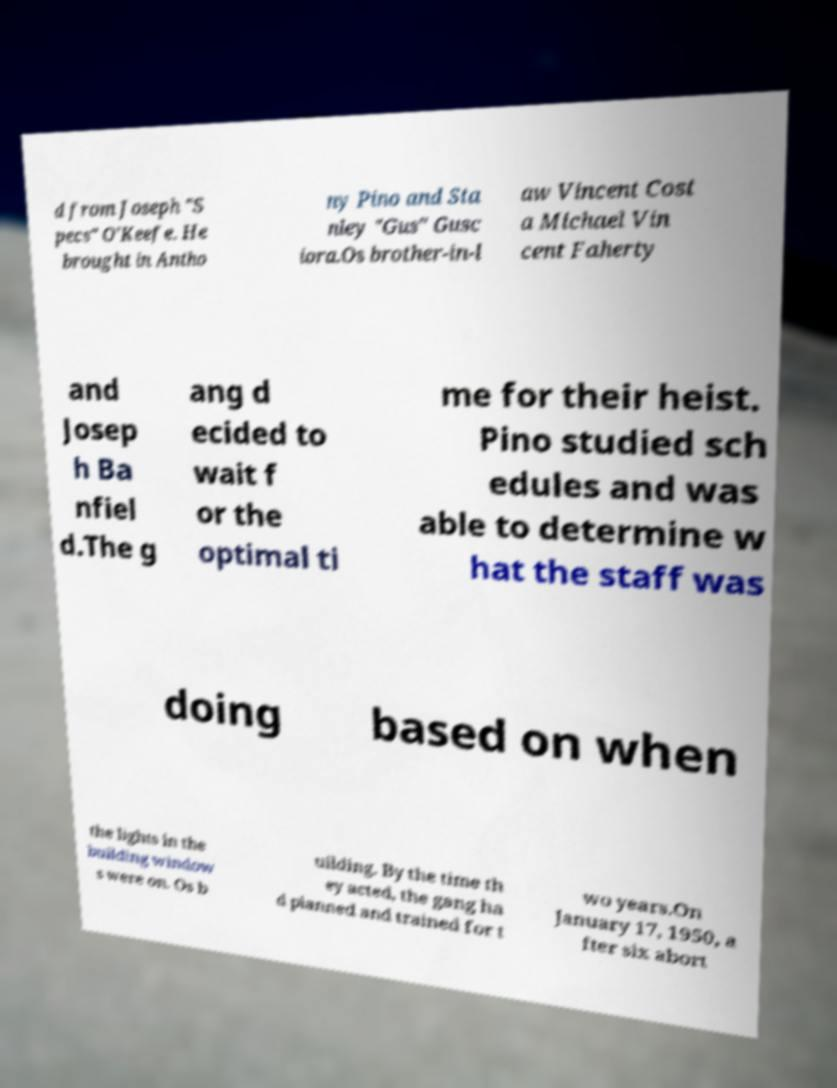What messages or text are displayed in this image? I need them in a readable, typed format. d from Joseph "S pecs" O'Keefe. He brought in Antho ny Pino and Sta nley "Gus" Gusc iora.Os brother-in-l aw Vincent Cost a Michael Vin cent Faherty and Josep h Ba nfiel d.The g ang d ecided to wait f or the optimal ti me for their heist. Pino studied sch edules and was able to determine w hat the staff was doing based on when the lights in the building window s were on. Os b uilding. By the time th ey acted, the gang ha d planned and trained for t wo years.On January 17, 1950, a fter six abort 